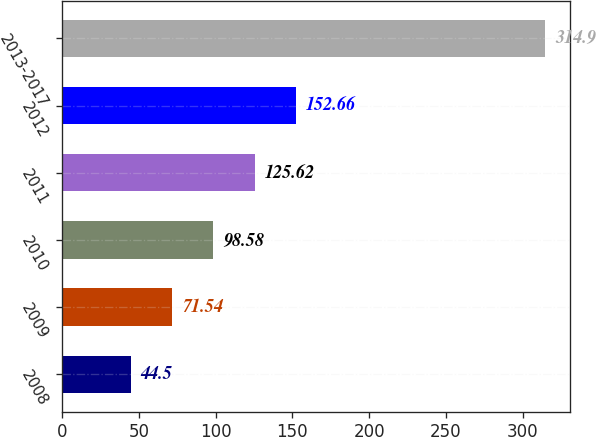<chart> <loc_0><loc_0><loc_500><loc_500><bar_chart><fcel>2008<fcel>2009<fcel>2010<fcel>2011<fcel>2012<fcel>2013-2017<nl><fcel>44.5<fcel>71.54<fcel>98.58<fcel>125.62<fcel>152.66<fcel>314.9<nl></chart> 